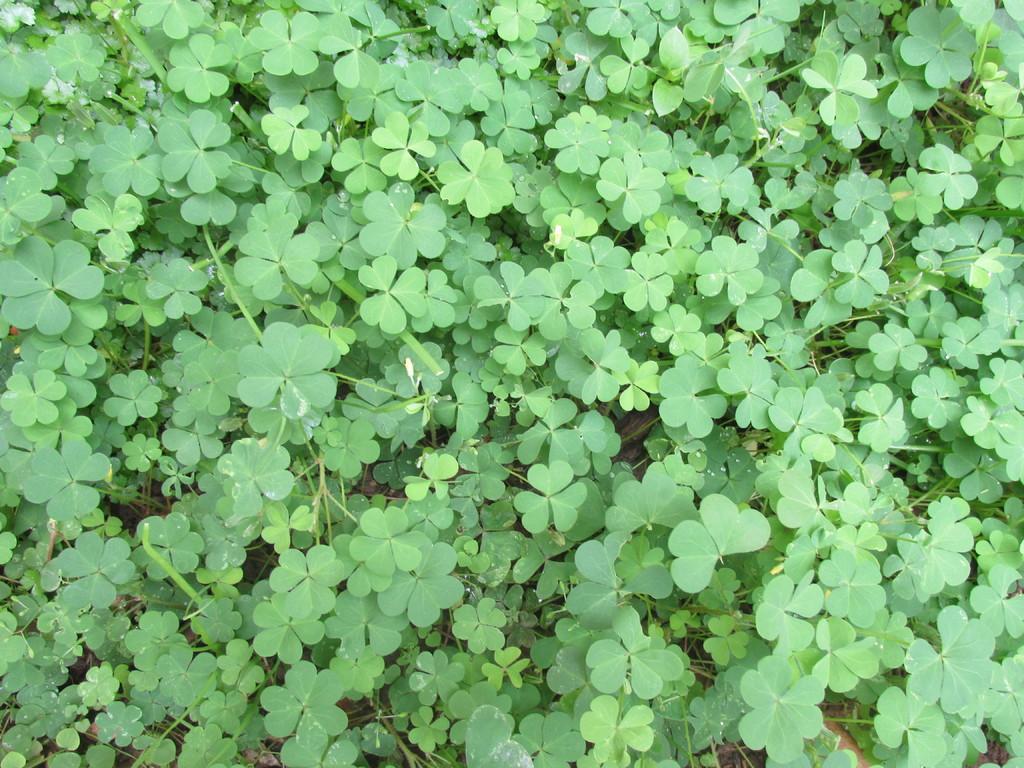In one or two sentences, can you explain what this image depicts? In this image we can see plants. 